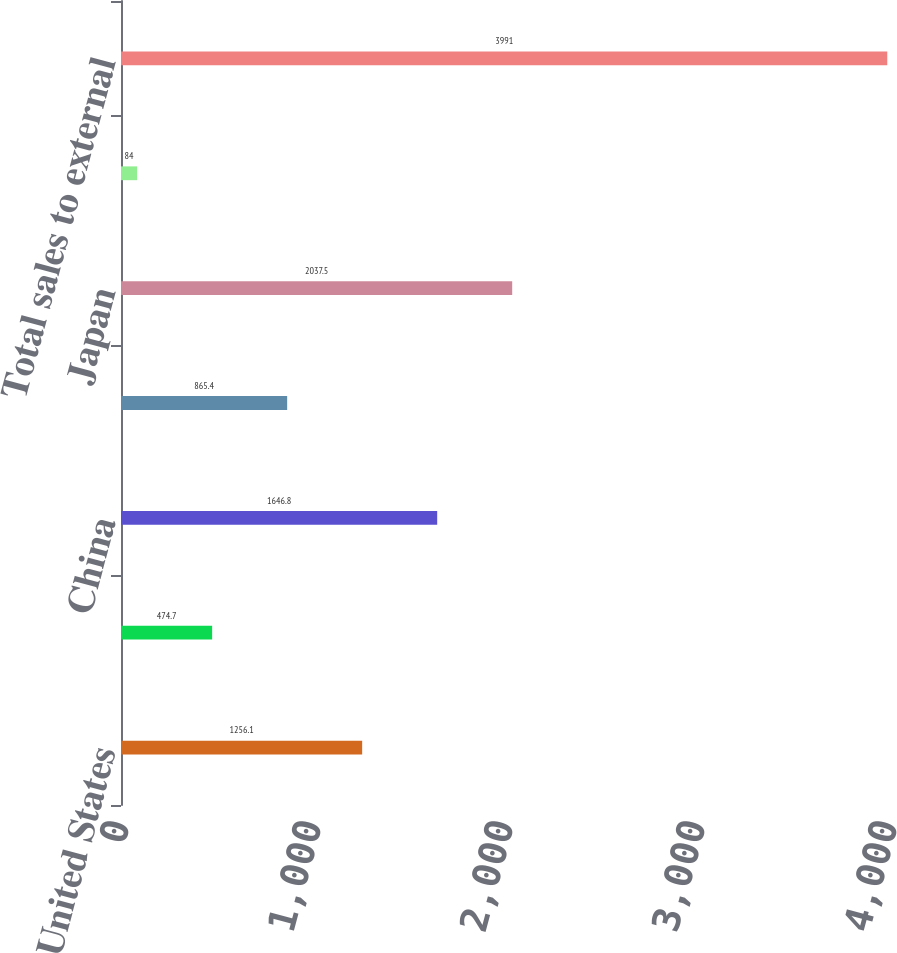Convert chart. <chart><loc_0><loc_0><loc_500><loc_500><bar_chart><fcel>United States<fcel>Europe<fcel>China<fcel>Singapore<fcel>Japan<fcel>Other countries<fcel>Total sales to external<nl><fcel>1256.1<fcel>474.7<fcel>1646.8<fcel>865.4<fcel>2037.5<fcel>84<fcel>3991<nl></chart> 